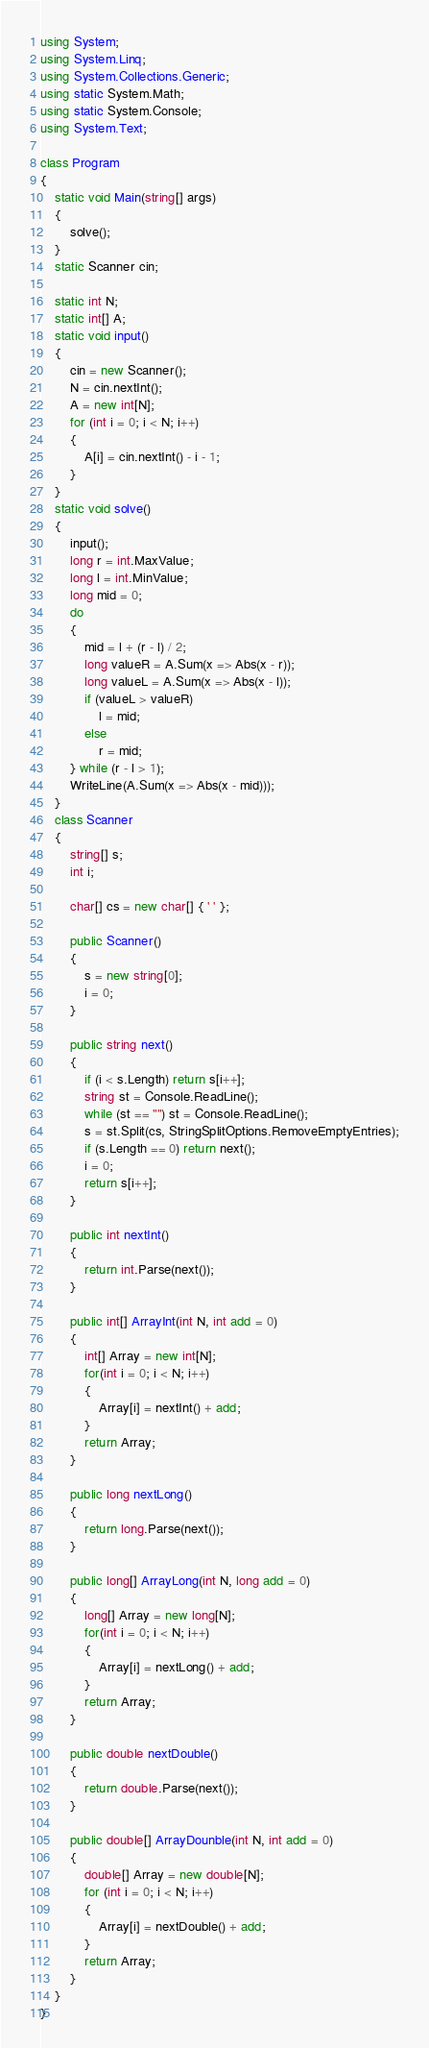Convert code to text. <code><loc_0><loc_0><loc_500><loc_500><_C#_>using System;
using System.Linq;
using System.Collections.Generic;
using static System.Math;
using static System.Console;
using System.Text;

class Program
{
    static void Main(string[] args)
    {
        solve();
    }
    static Scanner cin;

    static int N;
    static int[] A;
    static void input()
    {
        cin = new Scanner();
        N = cin.nextInt();
        A = new int[N];
        for (int i = 0; i < N; i++)
        {
            A[i] = cin.nextInt() - i - 1;
        }
    }
    static void solve()
    {
        input();
        long r = int.MaxValue;
        long l = int.MinValue;
        long mid = 0;
        do
        {
            mid = l + (r - l) / 2;
            long valueR = A.Sum(x => Abs(x - r));
            long valueL = A.Sum(x => Abs(x - l));
            if (valueL > valueR)
                l = mid;
            else
                r = mid;
        } while (r - l > 1);
        WriteLine(A.Sum(x => Abs(x - mid)));
    }
    class Scanner
    {
        string[] s;
        int i;

        char[] cs = new char[] { ' ' };

        public Scanner()
        {
            s = new string[0];
            i = 0;
        }
        
        public string next()
        {
            if (i < s.Length) return s[i++];
            string st = Console.ReadLine();
            while (st == "") st = Console.ReadLine();
            s = st.Split(cs, StringSplitOptions.RemoveEmptyEntries);
            if (s.Length == 0) return next();
            i = 0;
            return s[i++];
        }

        public int nextInt()
        {
            return int.Parse(next());
        }

        public int[] ArrayInt(int N, int add = 0)
        {
            int[] Array = new int[N];
            for(int i = 0; i < N; i++)
            {
                Array[i] = nextInt() + add;
            }
            return Array;
        }

        public long nextLong()
        {
            return long.Parse(next());
        }

        public long[] ArrayLong(int N, long add = 0)
        {
            long[] Array = new long[N];
            for(int i = 0; i < N; i++)
            {
                Array[i] = nextLong() + add;
            }
            return Array;
        }

        public double nextDouble()
        {
            return double.Parse(next());
        }

        public double[] ArrayDounble(int N, int add = 0)
        {
            double[] Array = new double[N];
            for (int i = 0; i < N; i++)
            {
                Array[i] = nextDouble() + add;
            }
            return Array;
        }
    }
}</code> 